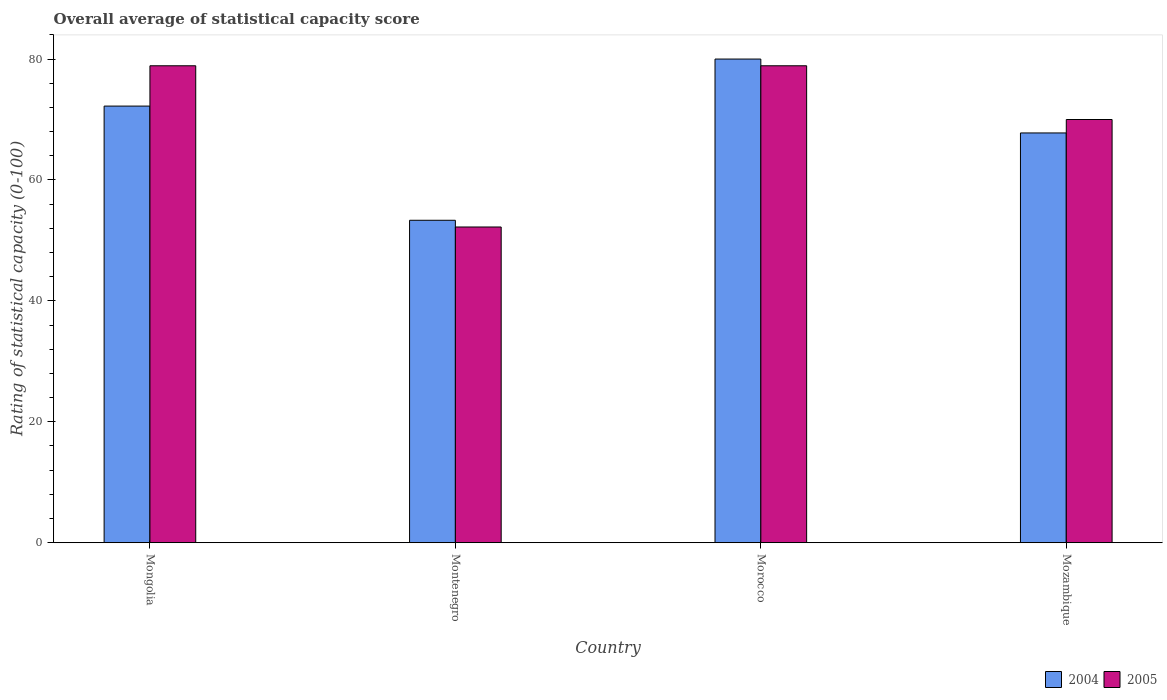Are the number of bars on each tick of the X-axis equal?
Ensure brevity in your answer.  Yes. What is the label of the 1st group of bars from the left?
Offer a terse response. Mongolia. In how many cases, is the number of bars for a given country not equal to the number of legend labels?
Provide a short and direct response. 0. What is the rating of statistical capacity in 2004 in Mozambique?
Your answer should be very brief. 67.78. Across all countries, what is the minimum rating of statistical capacity in 2005?
Give a very brief answer. 52.22. In which country was the rating of statistical capacity in 2004 maximum?
Provide a short and direct response. Morocco. In which country was the rating of statistical capacity in 2004 minimum?
Give a very brief answer. Montenegro. What is the total rating of statistical capacity in 2005 in the graph?
Make the answer very short. 280. What is the difference between the rating of statistical capacity in 2004 in Montenegro and that in Morocco?
Offer a very short reply. -26.67. What is the difference between the rating of statistical capacity in 2004 in Mongolia and the rating of statistical capacity in 2005 in Mozambique?
Your answer should be compact. 2.22. What is the average rating of statistical capacity in 2005 per country?
Offer a terse response. 70. What is the difference between the rating of statistical capacity of/in 2005 and rating of statistical capacity of/in 2004 in Mozambique?
Provide a succinct answer. 2.22. What is the ratio of the rating of statistical capacity in 2004 in Montenegro to that in Morocco?
Offer a very short reply. 0.67. Is the rating of statistical capacity in 2004 in Mongolia less than that in Montenegro?
Keep it short and to the point. No. What is the difference between the highest and the second highest rating of statistical capacity in 2005?
Offer a very short reply. -8.89. What is the difference between the highest and the lowest rating of statistical capacity in 2004?
Ensure brevity in your answer.  26.67. Is the sum of the rating of statistical capacity in 2005 in Mongolia and Morocco greater than the maximum rating of statistical capacity in 2004 across all countries?
Offer a terse response. Yes. What does the 2nd bar from the left in Mongolia represents?
Offer a very short reply. 2005. How many bars are there?
Make the answer very short. 8. Are all the bars in the graph horizontal?
Keep it short and to the point. No. Are the values on the major ticks of Y-axis written in scientific E-notation?
Offer a very short reply. No. Does the graph contain any zero values?
Provide a succinct answer. No. Does the graph contain grids?
Give a very brief answer. No. Where does the legend appear in the graph?
Offer a very short reply. Bottom right. How many legend labels are there?
Your answer should be very brief. 2. What is the title of the graph?
Ensure brevity in your answer.  Overall average of statistical capacity score. What is the label or title of the Y-axis?
Keep it short and to the point. Rating of statistical capacity (0-100). What is the Rating of statistical capacity (0-100) of 2004 in Mongolia?
Your response must be concise. 72.22. What is the Rating of statistical capacity (0-100) of 2005 in Mongolia?
Keep it short and to the point. 78.89. What is the Rating of statistical capacity (0-100) of 2004 in Montenegro?
Make the answer very short. 53.33. What is the Rating of statistical capacity (0-100) of 2005 in Montenegro?
Give a very brief answer. 52.22. What is the Rating of statistical capacity (0-100) of 2004 in Morocco?
Your answer should be compact. 80. What is the Rating of statistical capacity (0-100) of 2005 in Morocco?
Your response must be concise. 78.89. What is the Rating of statistical capacity (0-100) of 2004 in Mozambique?
Offer a very short reply. 67.78. What is the Rating of statistical capacity (0-100) of 2005 in Mozambique?
Make the answer very short. 70. Across all countries, what is the maximum Rating of statistical capacity (0-100) of 2004?
Your response must be concise. 80. Across all countries, what is the maximum Rating of statistical capacity (0-100) in 2005?
Make the answer very short. 78.89. Across all countries, what is the minimum Rating of statistical capacity (0-100) in 2004?
Keep it short and to the point. 53.33. Across all countries, what is the minimum Rating of statistical capacity (0-100) of 2005?
Provide a short and direct response. 52.22. What is the total Rating of statistical capacity (0-100) of 2004 in the graph?
Make the answer very short. 273.33. What is the total Rating of statistical capacity (0-100) of 2005 in the graph?
Your response must be concise. 280. What is the difference between the Rating of statistical capacity (0-100) in 2004 in Mongolia and that in Montenegro?
Provide a succinct answer. 18.89. What is the difference between the Rating of statistical capacity (0-100) of 2005 in Mongolia and that in Montenegro?
Keep it short and to the point. 26.67. What is the difference between the Rating of statistical capacity (0-100) in 2004 in Mongolia and that in Morocco?
Your answer should be very brief. -7.78. What is the difference between the Rating of statistical capacity (0-100) in 2004 in Mongolia and that in Mozambique?
Your response must be concise. 4.44. What is the difference between the Rating of statistical capacity (0-100) of 2005 in Mongolia and that in Mozambique?
Ensure brevity in your answer.  8.89. What is the difference between the Rating of statistical capacity (0-100) of 2004 in Montenegro and that in Morocco?
Offer a terse response. -26.67. What is the difference between the Rating of statistical capacity (0-100) in 2005 in Montenegro and that in Morocco?
Your response must be concise. -26.67. What is the difference between the Rating of statistical capacity (0-100) of 2004 in Montenegro and that in Mozambique?
Your response must be concise. -14.44. What is the difference between the Rating of statistical capacity (0-100) in 2005 in Montenegro and that in Mozambique?
Keep it short and to the point. -17.78. What is the difference between the Rating of statistical capacity (0-100) of 2004 in Morocco and that in Mozambique?
Keep it short and to the point. 12.22. What is the difference between the Rating of statistical capacity (0-100) of 2005 in Morocco and that in Mozambique?
Your response must be concise. 8.89. What is the difference between the Rating of statistical capacity (0-100) of 2004 in Mongolia and the Rating of statistical capacity (0-100) of 2005 in Montenegro?
Your response must be concise. 20. What is the difference between the Rating of statistical capacity (0-100) of 2004 in Mongolia and the Rating of statistical capacity (0-100) of 2005 in Morocco?
Offer a very short reply. -6.67. What is the difference between the Rating of statistical capacity (0-100) in 2004 in Mongolia and the Rating of statistical capacity (0-100) in 2005 in Mozambique?
Your answer should be very brief. 2.22. What is the difference between the Rating of statistical capacity (0-100) in 2004 in Montenegro and the Rating of statistical capacity (0-100) in 2005 in Morocco?
Your answer should be very brief. -25.56. What is the difference between the Rating of statistical capacity (0-100) of 2004 in Montenegro and the Rating of statistical capacity (0-100) of 2005 in Mozambique?
Ensure brevity in your answer.  -16.67. What is the difference between the Rating of statistical capacity (0-100) of 2004 in Morocco and the Rating of statistical capacity (0-100) of 2005 in Mozambique?
Offer a terse response. 10. What is the average Rating of statistical capacity (0-100) in 2004 per country?
Provide a succinct answer. 68.33. What is the average Rating of statistical capacity (0-100) of 2005 per country?
Your answer should be very brief. 70. What is the difference between the Rating of statistical capacity (0-100) in 2004 and Rating of statistical capacity (0-100) in 2005 in Mongolia?
Provide a succinct answer. -6.67. What is the difference between the Rating of statistical capacity (0-100) of 2004 and Rating of statistical capacity (0-100) of 2005 in Montenegro?
Offer a very short reply. 1.11. What is the difference between the Rating of statistical capacity (0-100) of 2004 and Rating of statistical capacity (0-100) of 2005 in Mozambique?
Keep it short and to the point. -2.22. What is the ratio of the Rating of statistical capacity (0-100) in 2004 in Mongolia to that in Montenegro?
Your answer should be very brief. 1.35. What is the ratio of the Rating of statistical capacity (0-100) in 2005 in Mongolia to that in Montenegro?
Give a very brief answer. 1.51. What is the ratio of the Rating of statistical capacity (0-100) in 2004 in Mongolia to that in Morocco?
Your answer should be very brief. 0.9. What is the ratio of the Rating of statistical capacity (0-100) of 2004 in Mongolia to that in Mozambique?
Make the answer very short. 1.07. What is the ratio of the Rating of statistical capacity (0-100) in 2005 in Mongolia to that in Mozambique?
Provide a succinct answer. 1.13. What is the ratio of the Rating of statistical capacity (0-100) of 2005 in Montenegro to that in Morocco?
Provide a succinct answer. 0.66. What is the ratio of the Rating of statistical capacity (0-100) of 2004 in Montenegro to that in Mozambique?
Give a very brief answer. 0.79. What is the ratio of the Rating of statistical capacity (0-100) in 2005 in Montenegro to that in Mozambique?
Your response must be concise. 0.75. What is the ratio of the Rating of statistical capacity (0-100) of 2004 in Morocco to that in Mozambique?
Make the answer very short. 1.18. What is the ratio of the Rating of statistical capacity (0-100) of 2005 in Morocco to that in Mozambique?
Ensure brevity in your answer.  1.13. What is the difference between the highest and the second highest Rating of statistical capacity (0-100) in 2004?
Your answer should be compact. 7.78. What is the difference between the highest and the second highest Rating of statistical capacity (0-100) in 2005?
Provide a succinct answer. 0. What is the difference between the highest and the lowest Rating of statistical capacity (0-100) in 2004?
Provide a succinct answer. 26.67. What is the difference between the highest and the lowest Rating of statistical capacity (0-100) in 2005?
Your response must be concise. 26.67. 